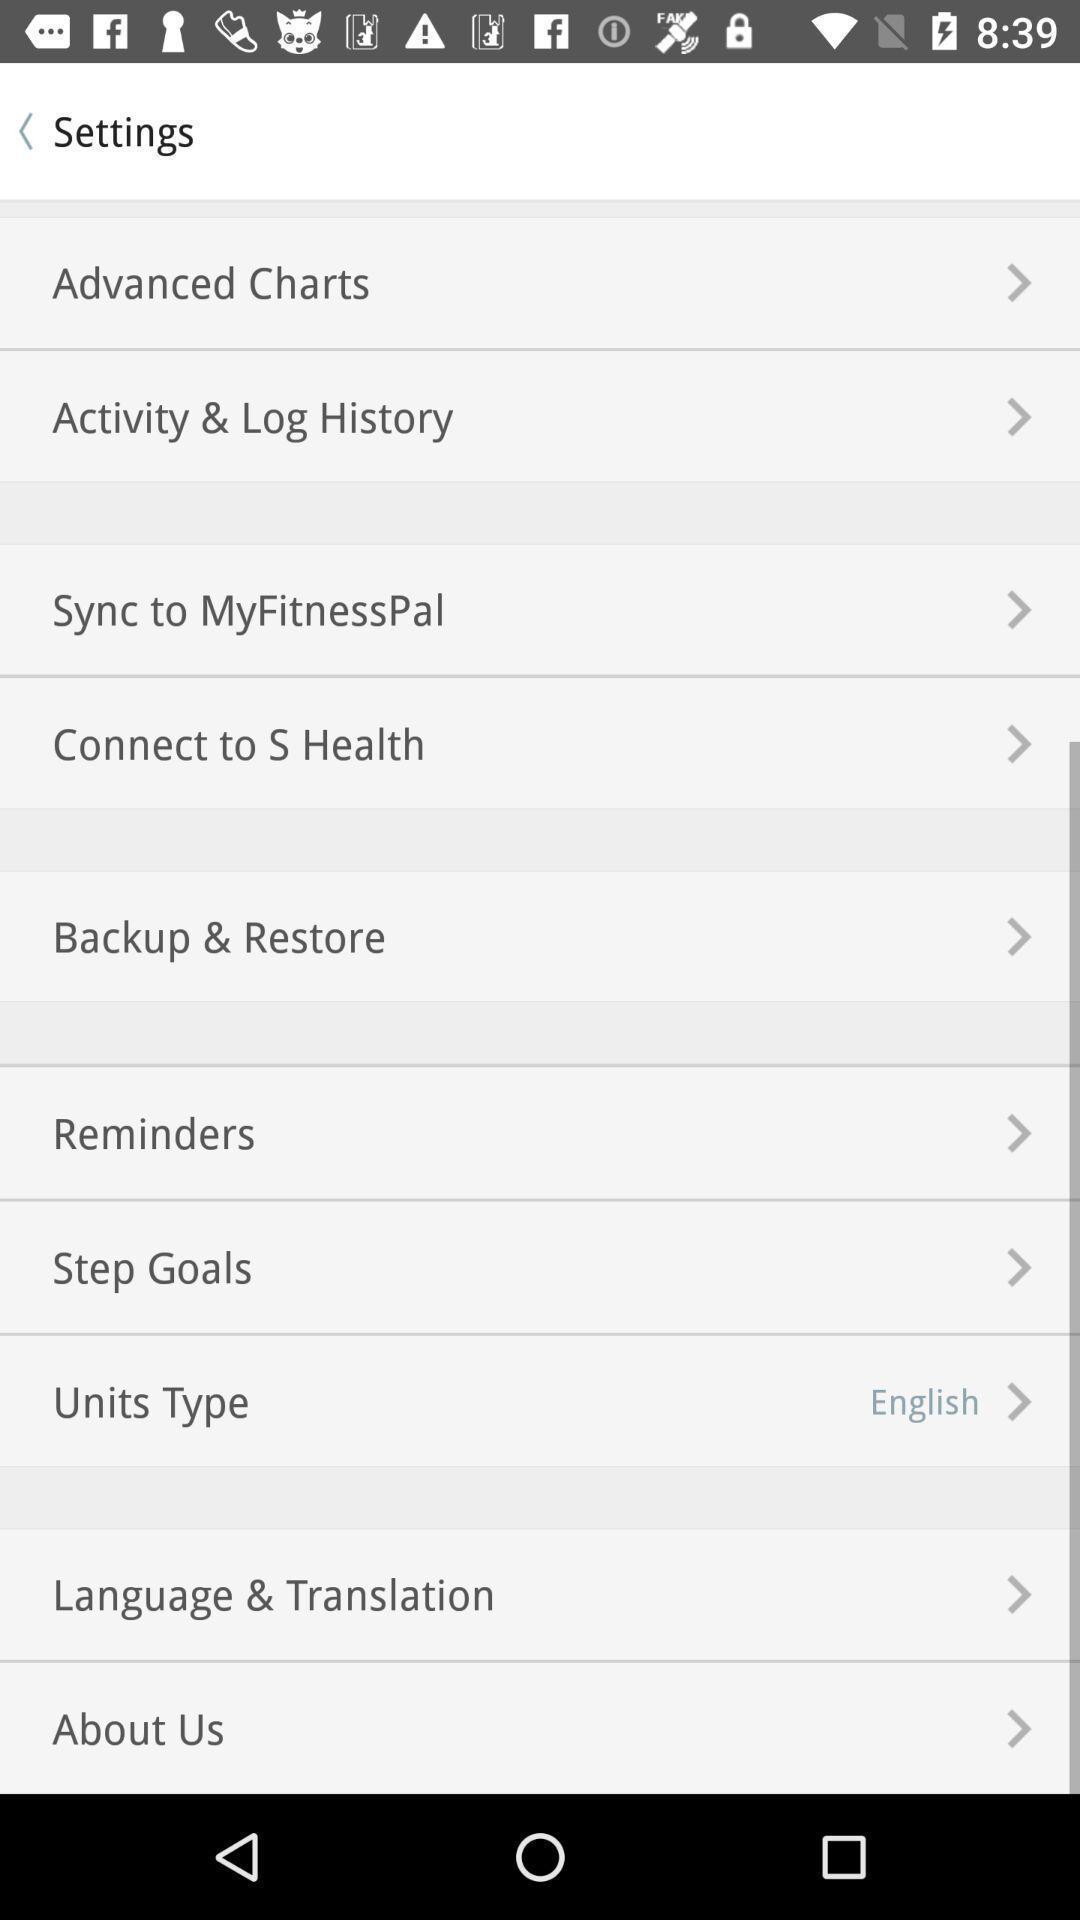What can you discern from this picture? Setting page displaying the various options in fitness tracker application. 